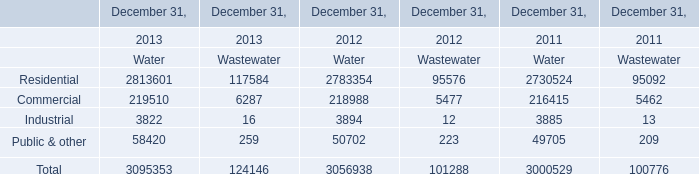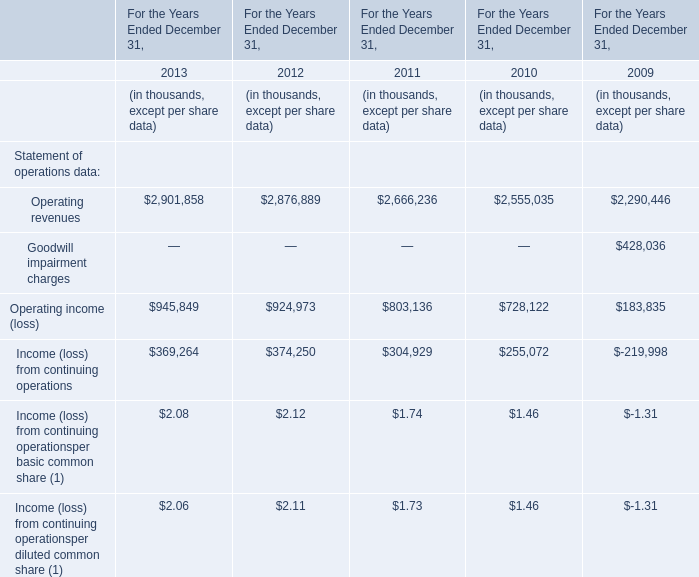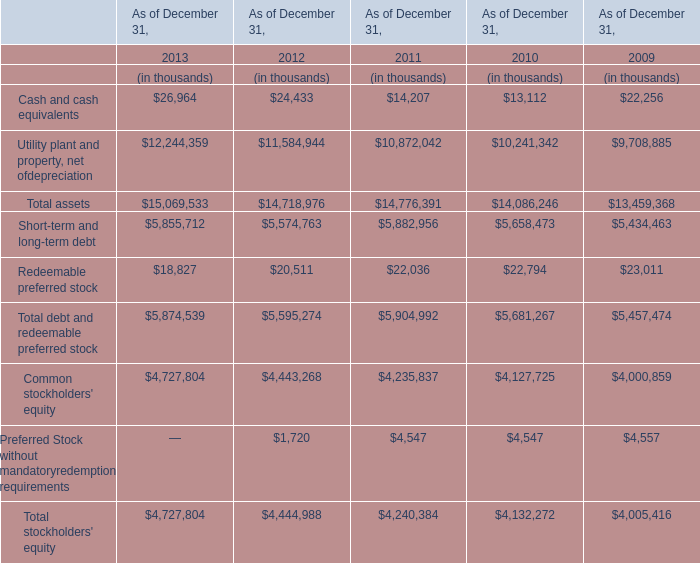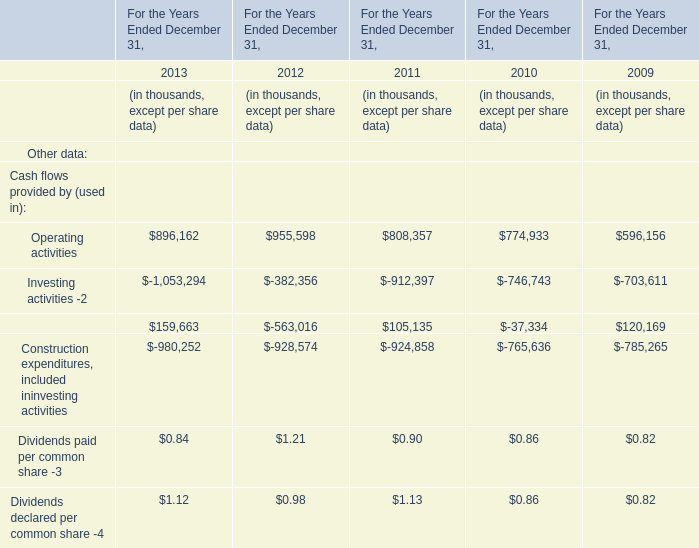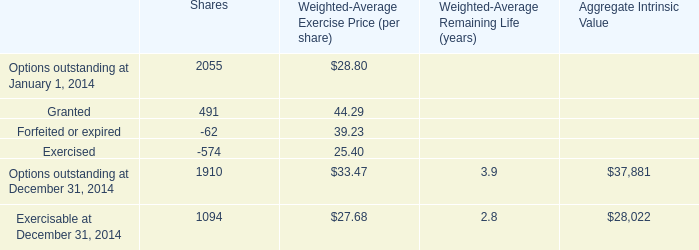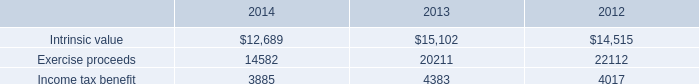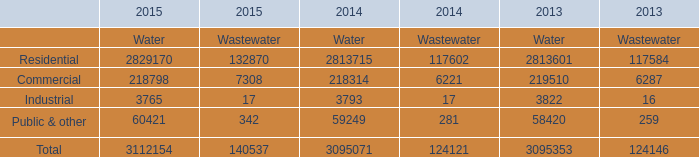In the year with lowest amount of Operating activities, what's the increasing rate of Dividends declared per common share -4? 
Computations: ((0.86 - 0.82) / 0.82)
Answer: 0.04878. 